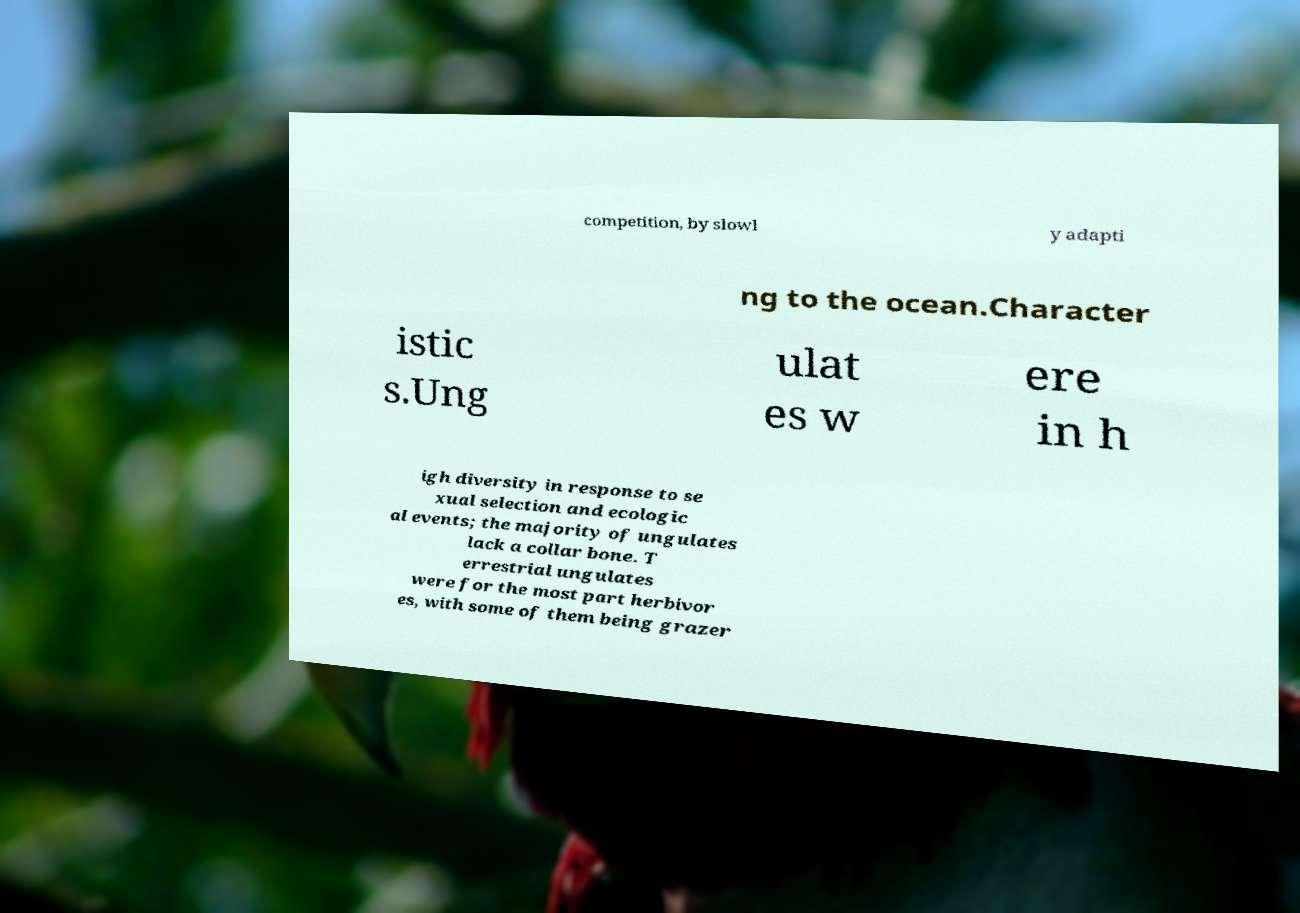I need the written content from this picture converted into text. Can you do that? competition, by slowl y adapti ng to the ocean.Character istic s.Ung ulat es w ere in h igh diversity in response to se xual selection and ecologic al events; the majority of ungulates lack a collar bone. T errestrial ungulates were for the most part herbivor es, with some of them being grazer 